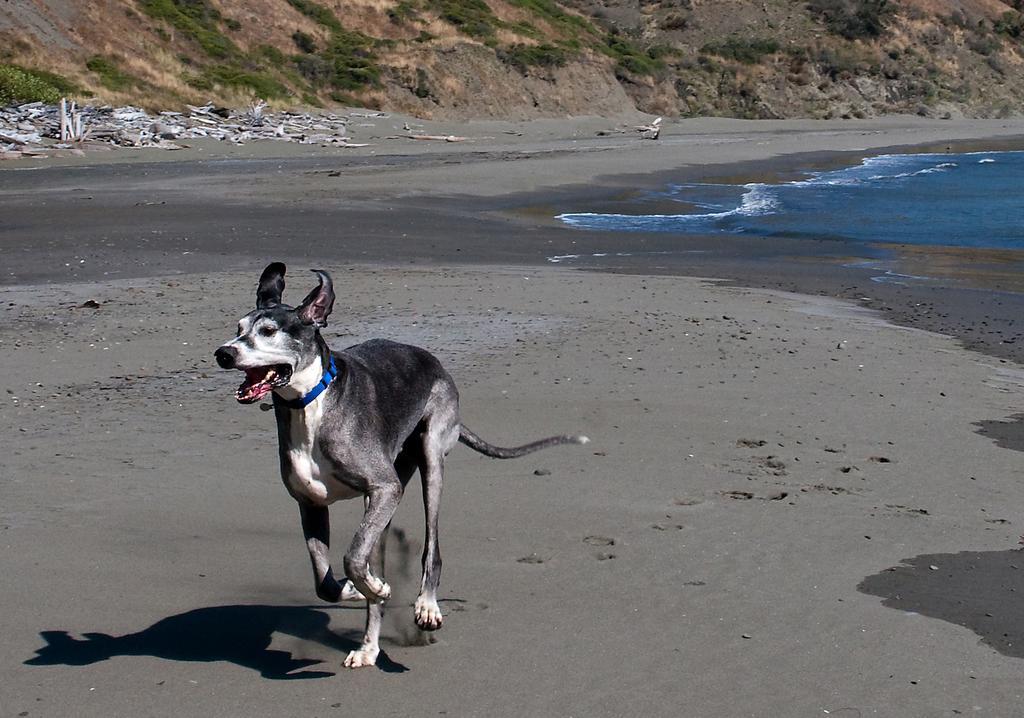Please provide a concise description of this image. In this image we can see a dog running on the ground, there are plants, mountains, also we can see the water, and the dirt. 